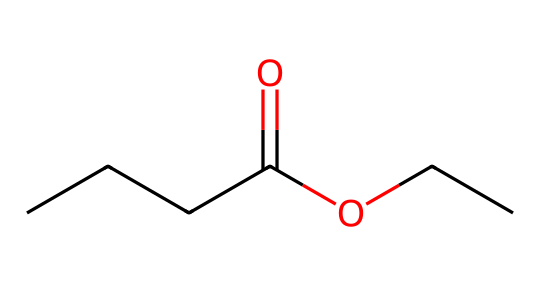What is the name of this chemical? The SMILES notation "CCCC(=O)OCC" represents ethyl butyrate, as the structure indicates it's an ester formed from butanoic acid and ethanol.
Answer: ethyl butyrate How many carbon atoms are in ethyl butyrate? The SMILES notation reveals that there are five carbon atoms: four in the butyl group (CCCC) and one in the ethyl group (C).
Answer: 5 What type of functional group is present in ethyl butyrate? The presence of the -O- and =O groups in the structure indicates the presence of an ester functional group, which is characteristic of flavoring and fragrance compounds.
Answer: ester What is the molecular formula of ethyl butyrate? By counting the atoms directly from the SMILES, there are five carbons (C), ten hydrogens (H), and two oxygens (O), leading to the molecular formula C5H10O2.
Answer: C5H10O2 What is the main aroma characteristic of ethyl butyrate? Ethyl butyrate is known for imparting a fruity aroma, often reminiscent of tropical fruits like pineapple or peach, which is valuable in artificial flavorings.
Answer: fruity Why is ethyl butyrate used in flavorings? Ethyl butyrate's specific structure allows it to produce a pleasant fruity scent, making it highly desirable in the food and fragrance industry to enhance flavor profiles.
Answer: pleasant fruity scent 